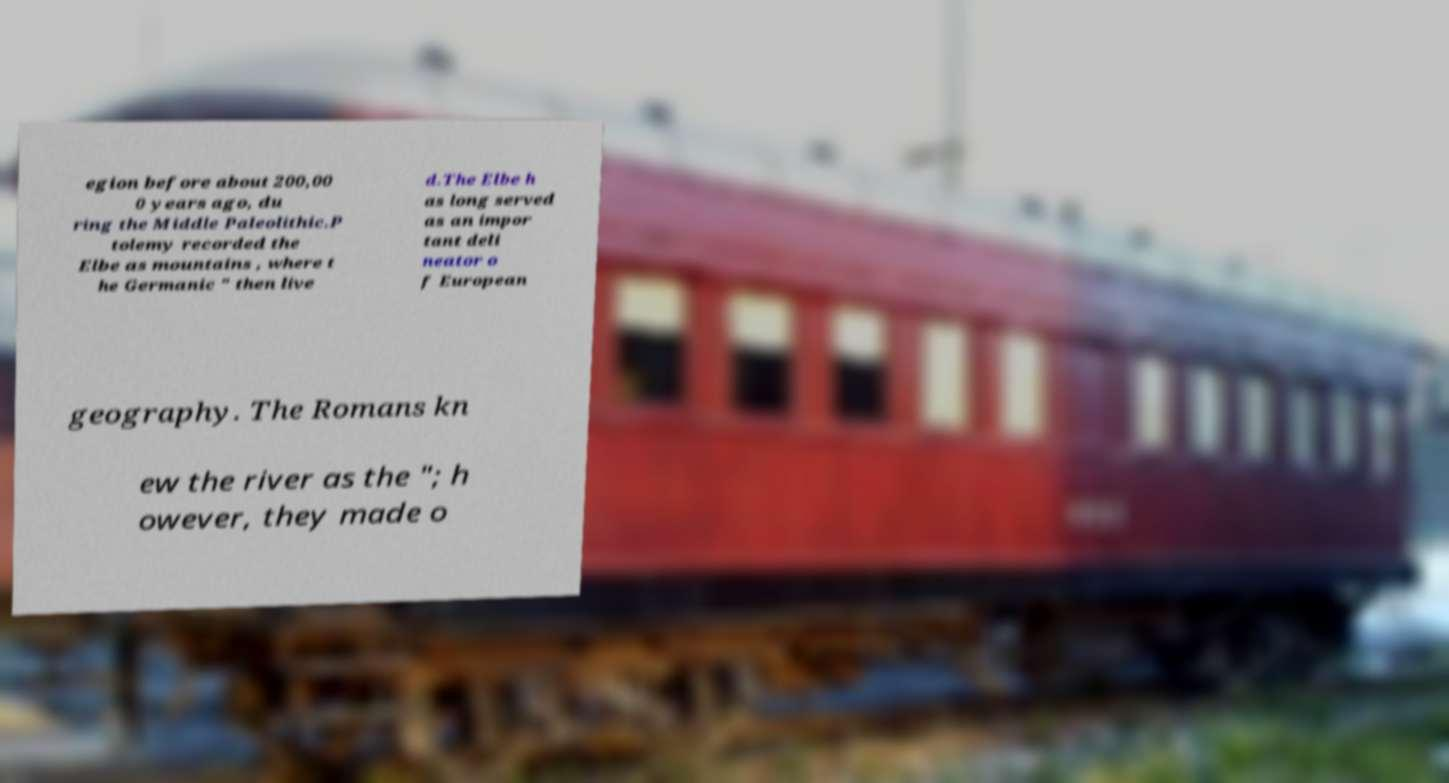There's text embedded in this image that I need extracted. Can you transcribe it verbatim? egion before about 200,00 0 years ago, du ring the Middle Paleolithic.P tolemy recorded the Elbe as mountains , where t he Germanic " then live d.The Elbe h as long served as an impor tant deli neator o f European geography. The Romans kn ew the river as the "; h owever, they made o 